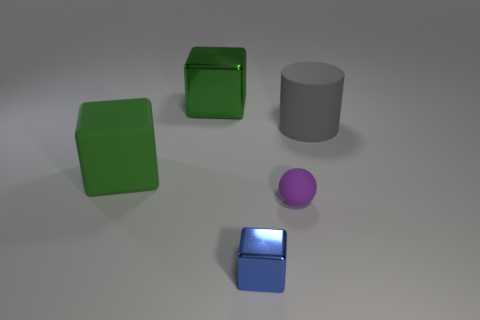Add 3 tiny blue shiny cubes. How many objects exist? 8 Subtract all green cubes. How many cubes are left? 1 Subtract all tiny blue shiny cubes. How many cubes are left? 2 Subtract 0 green balls. How many objects are left? 5 Subtract all cubes. How many objects are left? 2 Subtract 1 cylinders. How many cylinders are left? 0 Subtract all yellow cubes. Subtract all cyan cylinders. How many cubes are left? 3 Subtract all green spheres. How many yellow cubes are left? 0 Subtract all gray matte things. Subtract all tiny red shiny cubes. How many objects are left? 4 Add 5 large green rubber objects. How many large green rubber objects are left? 6 